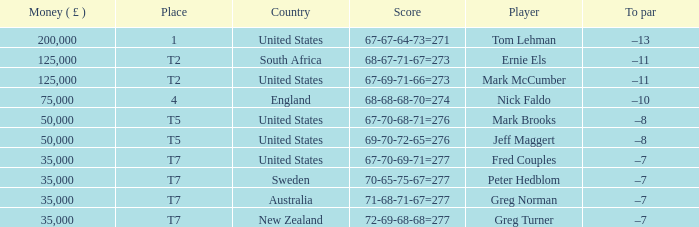What is the highest Money ( £ ), when Player is "Peter Hedblom"? 35000.0. 